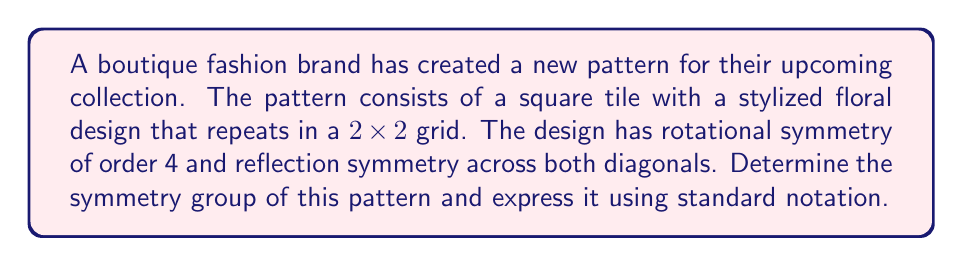Can you answer this question? To determine the symmetry group of the pattern, we need to identify all the symmetry operations that leave the pattern unchanged. Let's analyze the given information:

1. The pattern has rotational symmetry of order 4, meaning it remains unchanged after rotations of 0°, 90°, 180°, and 270°.
2. It has reflection symmetry across both diagonals.

These symmetries correspond to the following operations:
- Identity: $e$
- Rotations: $r$ (90° clockwise), $r^2$ (180°), $r^3$ (270° clockwise)
- Reflections: $d_1$ (across one diagonal), $d_2$ (across the other diagonal)

We can also deduce that there are two more reflections:
- Reflection across the vertical axis: $h$
- Reflection across the horizontal axis: $v$

This set of symmetries forms a group under composition. The group has 8 elements in total:
$${e, r, r^2, r^3, h, v, d_1, d_2}$$

This symmetry group is isomorphic to the dihedral group of order 8, denoted as $D_4$ (or $D_8$ in some notations).

The group $D_4$ is defined by the following presentation:
$$D_4 = \langle r, s \mid r^4 = e, s^2 = e, srs = r^{-1} \rangle$$

Where $r$ represents the rotation and $s$ represents a reflection.

This group is non-abelian and has the following properties:
- Order: 8
- Center: $\{e, r^2\}$
- It has 5 conjugacy classes
- It has 5 subgroups, including itself and the trivial subgroup

In the context of crystallography and wallpaper groups, this symmetry group is also known as p4m.
Answer: The symmetry group of the fashion pattern is $D_4$ (dihedral group of order 8), also known as the p4m wallpaper group. 